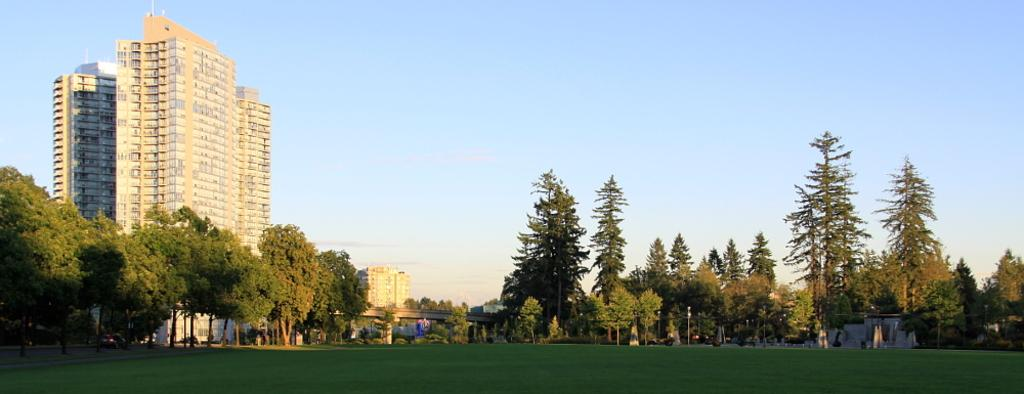What type of structures can be seen in the image? There are buildings in the image. What else is present in the image besides buildings? There are poles and trees visible in the image. What is the ground covered with in the image? Grass is visible on the ground in the image. What type of disease is affecting the trees in the image? There is no indication of any disease affecting the trees in the image; they appear healthy. 